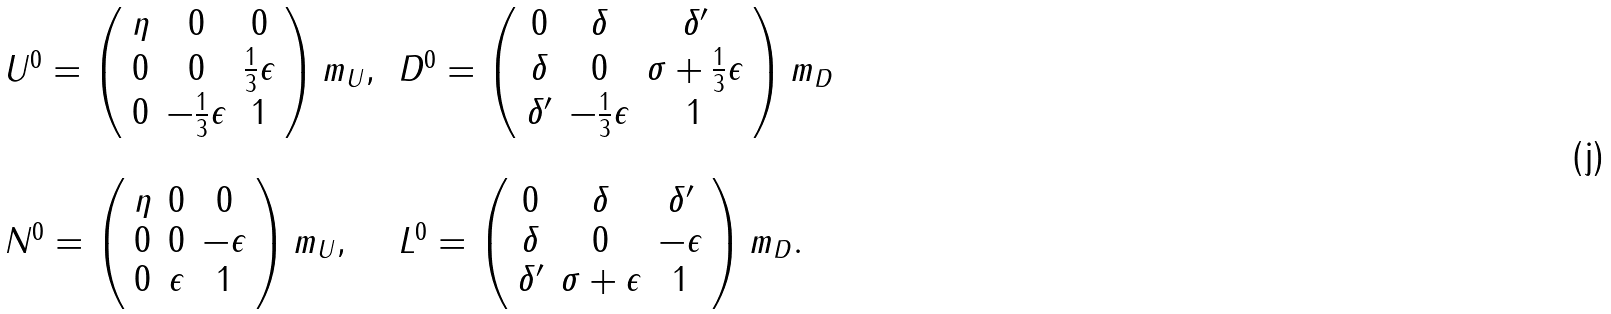Convert formula to latex. <formula><loc_0><loc_0><loc_500><loc_500>\begin{array} { l l } U ^ { 0 } = \left ( \begin{array} { c c c } \eta & 0 & 0 \\ 0 & 0 & \frac { 1 } { 3 } \epsilon \\ 0 & - \frac { 1 } { 3 } \epsilon & 1 \end{array} \right ) m _ { U } , \, & D ^ { 0 } = \left ( \begin{array} { c c c } 0 & \delta & \delta ^ { \prime } \\ \delta & 0 & \sigma + \frac { 1 } { 3 } \epsilon \\ \delta ^ { \prime } & - \frac { 1 } { 3 } \epsilon & 1 \end{array} \right ) m _ { D } \\ & \\ N ^ { 0 } = \left ( \begin{array} { c c c } \eta & 0 & 0 \\ 0 & 0 & - \epsilon \\ 0 & \epsilon & 1 \end{array} \right ) m _ { U } , \, & L ^ { 0 } = \left ( \begin{array} { c c c } 0 & \delta & \delta ^ { \prime } \\ \delta & 0 & - \epsilon \\ \delta ^ { \prime } & \sigma + \epsilon & 1 \end{array} \right ) m _ { D } . \end{array}</formula> 